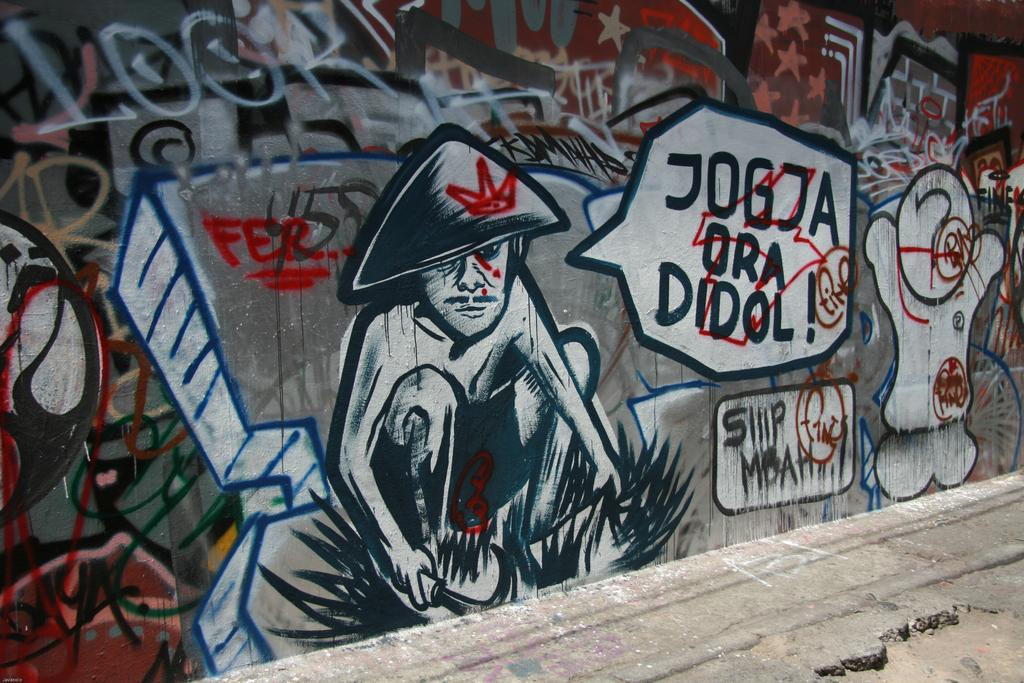What is the main feature of the image? There is a wall in the image. What is on the wall? The wall has paintings on it and there is text on the wall. What else can be seen in the image? The image shows a road at the bottom. How many times has the tiger been folded in the image? There is no tiger present in the image, so it cannot be folded or unfolded. 